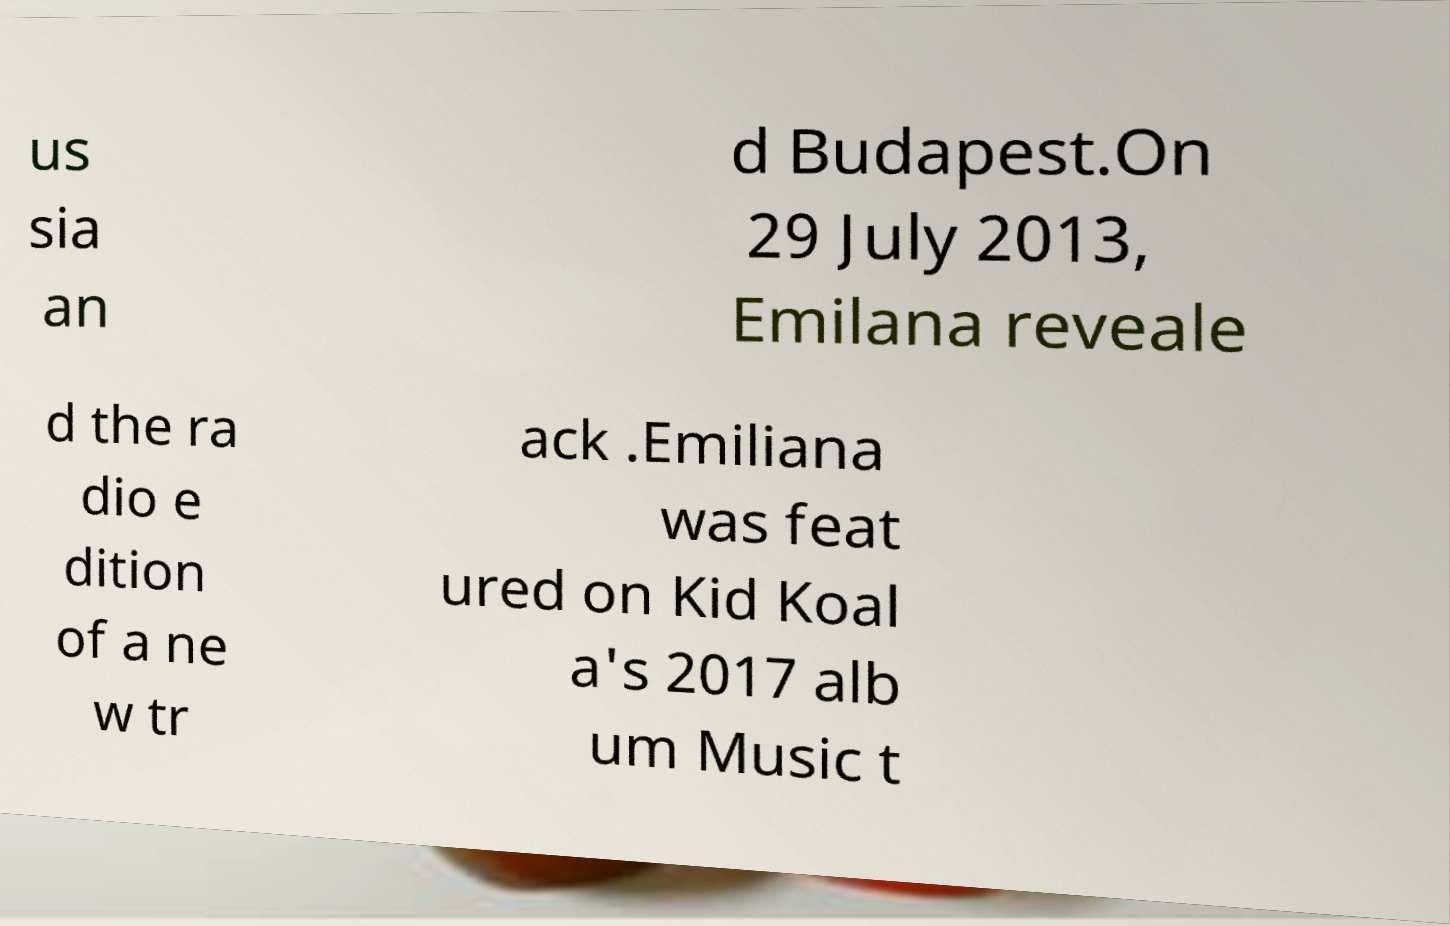There's text embedded in this image that I need extracted. Can you transcribe it verbatim? us sia an d Budapest.On 29 July 2013, Emilana reveale d the ra dio e dition of a ne w tr ack .Emiliana was feat ured on Kid Koal a's 2017 alb um Music t 